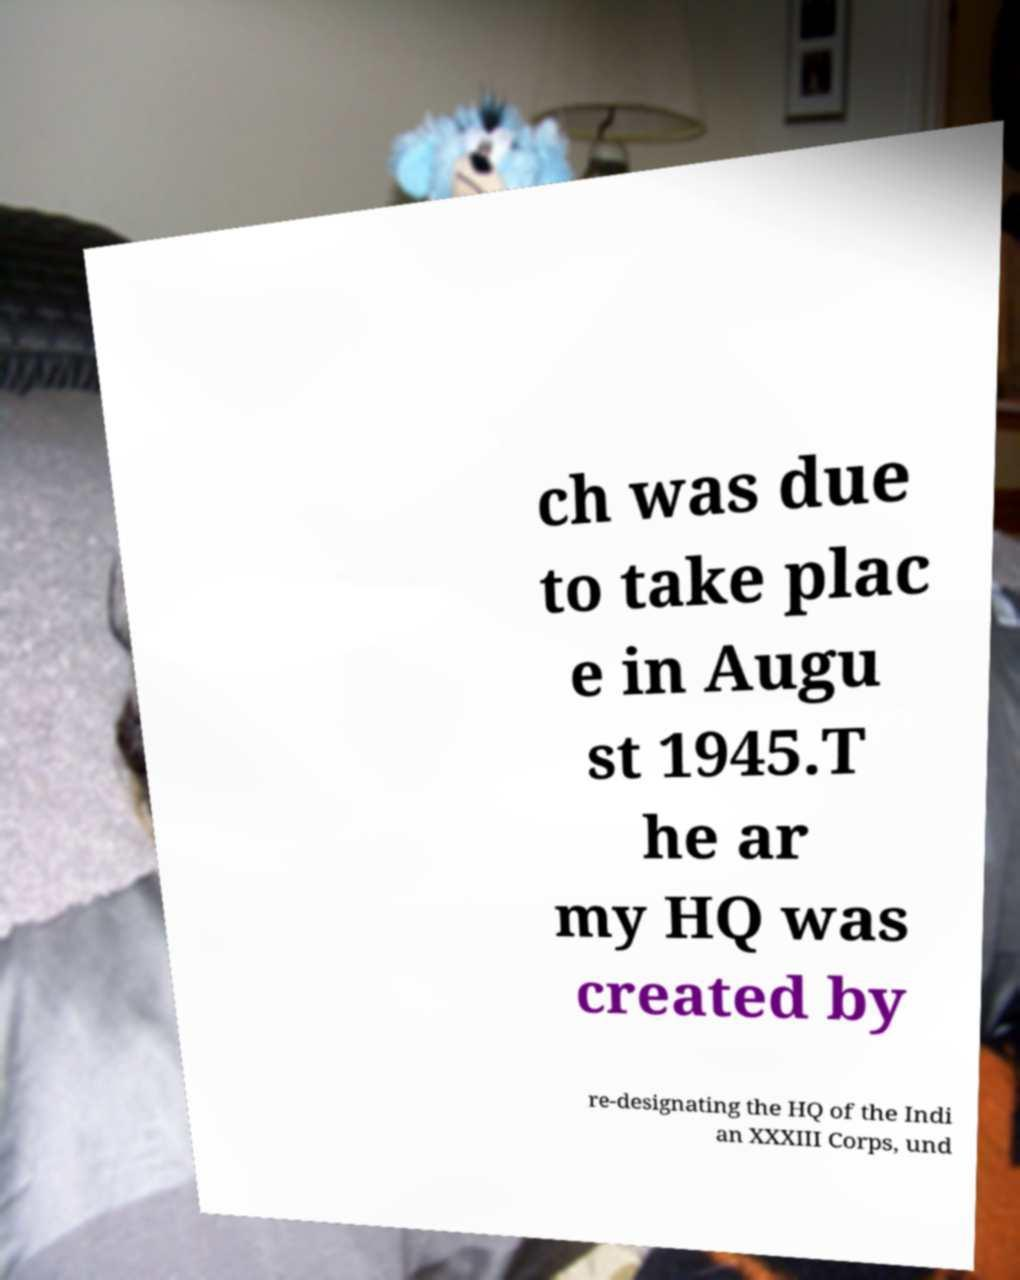I need the written content from this picture converted into text. Can you do that? ch was due to take plac e in Augu st 1945.T he ar my HQ was created by re-designating the HQ of the Indi an XXXIII Corps, und 